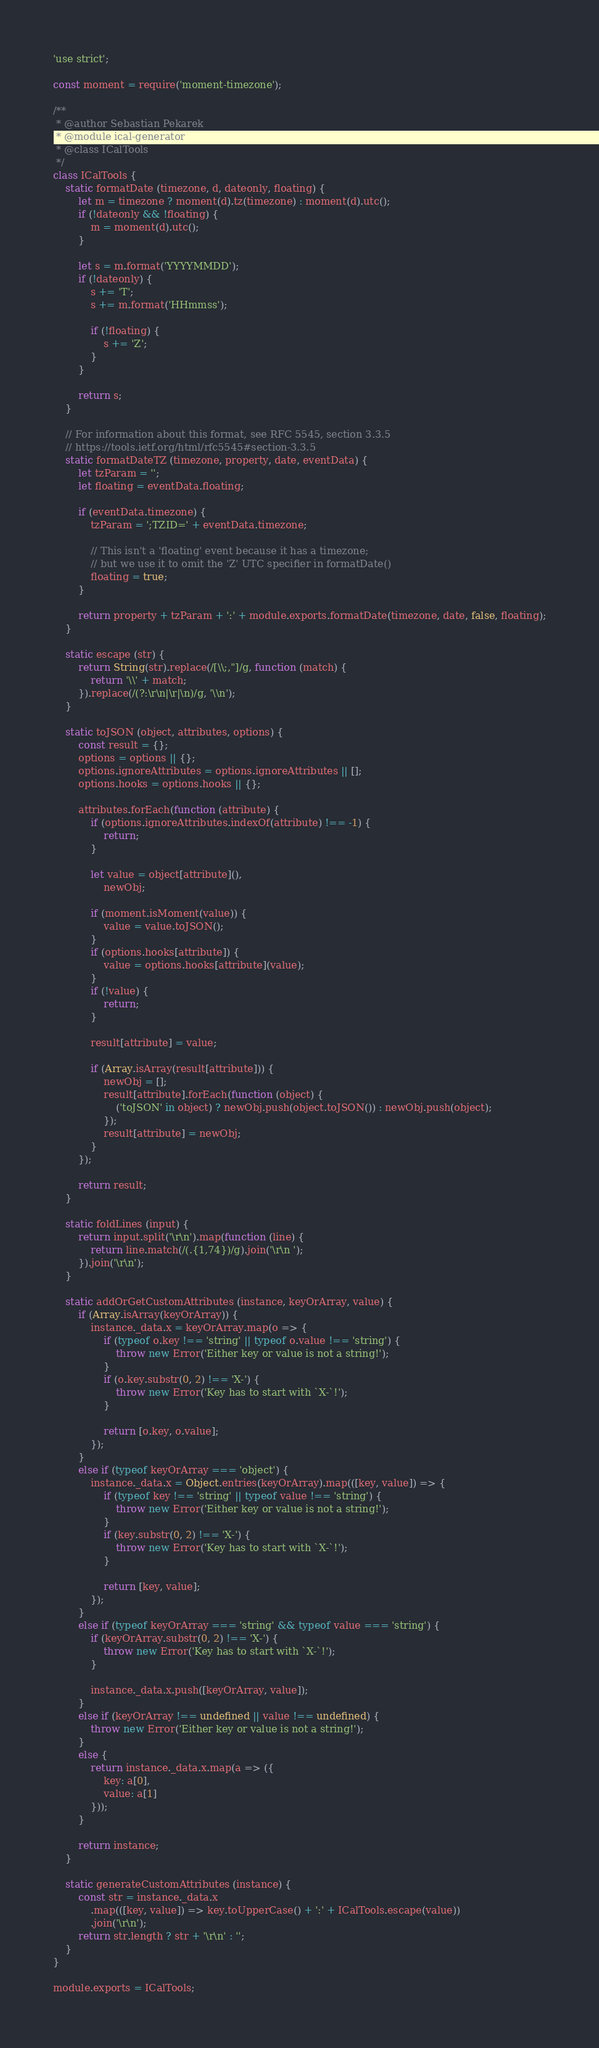<code> <loc_0><loc_0><loc_500><loc_500><_JavaScript_>'use strict';

const moment = require('moment-timezone');

/**
 * @author Sebastian Pekarek
 * @module ical-generator
 * @class ICalTools
 */
class ICalTools {
    static formatDate (timezone, d, dateonly, floating) {
        let m = timezone ? moment(d).tz(timezone) : moment(d).utc();
        if (!dateonly && !floating) {
            m = moment(d).utc();
        }

        let s = m.format('YYYYMMDD');
        if (!dateonly) {
            s += 'T';
            s += m.format('HHmmss');

            if (!floating) {
                s += 'Z';
            }
        }

        return s;
    }

    // For information about this format, see RFC 5545, section 3.3.5
    // https://tools.ietf.org/html/rfc5545#section-3.3.5
    static formatDateTZ (timezone, property, date, eventData) {
        let tzParam = '';
        let floating = eventData.floating;

        if (eventData.timezone) {
            tzParam = ';TZID=' + eventData.timezone;

            // This isn't a 'floating' event because it has a timezone;
            // but we use it to omit the 'Z' UTC specifier in formatDate()
            floating = true;
        }

        return property + tzParam + ':' + module.exports.formatDate(timezone, date, false, floating);
    }

    static escape (str) {
        return String(str).replace(/[\\;,"]/g, function (match) {
            return '\\' + match;
        }).replace(/(?:\r\n|\r|\n)/g, '\\n');
    }

    static toJSON (object, attributes, options) {
        const result = {};
        options = options || {};
        options.ignoreAttributes = options.ignoreAttributes || [];
        options.hooks = options.hooks || {};

        attributes.forEach(function (attribute) {
            if (options.ignoreAttributes.indexOf(attribute) !== -1) {
                return;
            }

            let value = object[attribute](),
                newObj;

            if (moment.isMoment(value)) {
                value = value.toJSON();
            }
            if (options.hooks[attribute]) {
                value = options.hooks[attribute](value);
            }
            if (!value) {
                return;
            }

            result[attribute] = value;

            if (Array.isArray(result[attribute])) {
                newObj = [];
                result[attribute].forEach(function (object) {
                    ('toJSON' in object) ? newObj.push(object.toJSON()) : newObj.push(object);
                });
                result[attribute] = newObj;
            }
        });

        return result;
    }

    static foldLines (input) {
        return input.split('\r\n').map(function (line) {
            return line.match(/(.{1,74})/g).join('\r\n ');
        }).join('\r\n');
    }

    static addOrGetCustomAttributes (instance, keyOrArray, value) {
        if (Array.isArray(keyOrArray)) {
            instance._data.x = keyOrArray.map(o => {
                if (typeof o.key !== 'string' || typeof o.value !== 'string') {
                    throw new Error('Either key or value is not a string!');
                }
                if (o.key.substr(0, 2) !== 'X-') {
                    throw new Error('Key has to start with `X-`!');
                }

                return [o.key, o.value];
            });
        }
        else if (typeof keyOrArray === 'object') {
            instance._data.x = Object.entries(keyOrArray).map(([key, value]) => {
                if (typeof key !== 'string' || typeof value !== 'string') {
                    throw new Error('Either key or value is not a string!');
                }
                if (key.substr(0, 2) !== 'X-') {
                    throw new Error('Key has to start with `X-`!');
                }

                return [key, value];
            });
        }
        else if (typeof keyOrArray === 'string' && typeof value === 'string') {
            if (keyOrArray.substr(0, 2) !== 'X-') {
                throw new Error('Key has to start with `X-`!');
            }

            instance._data.x.push([keyOrArray, value]);
        }
        else if (keyOrArray !== undefined || value !== undefined) {
            throw new Error('Either key or value is not a string!');
        }
        else {
            return instance._data.x.map(a => ({
                key: a[0],
                value: a[1]
            }));
        }

        return instance;
    }

    static generateCustomAttributes (instance) {
        const str = instance._data.x
            .map(([key, value]) => key.toUpperCase() + ':' + ICalTools.escape(value))
            .join('\r\n');
        return str.length ? str + '\r\n' : '';
    }
}

module.exports = ICalTools;
</code> 